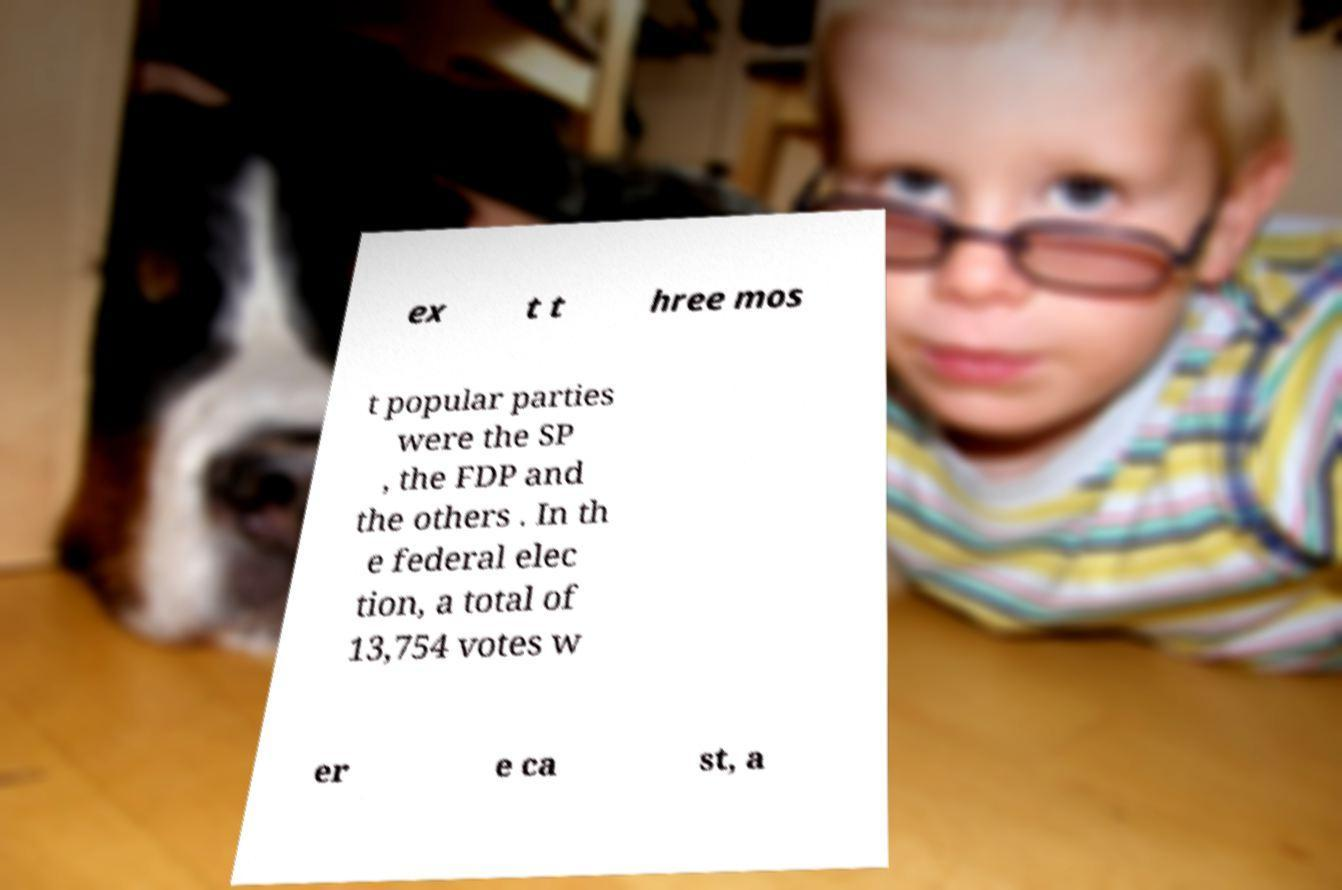There's text embedded in this image that I need extracted. Can you transcribe it verbatim? ex t t hree mos t popular parties were the SP , the FDP and the others . In th e federal elec tion, a total of 13,754 votes w er e ca st, a 